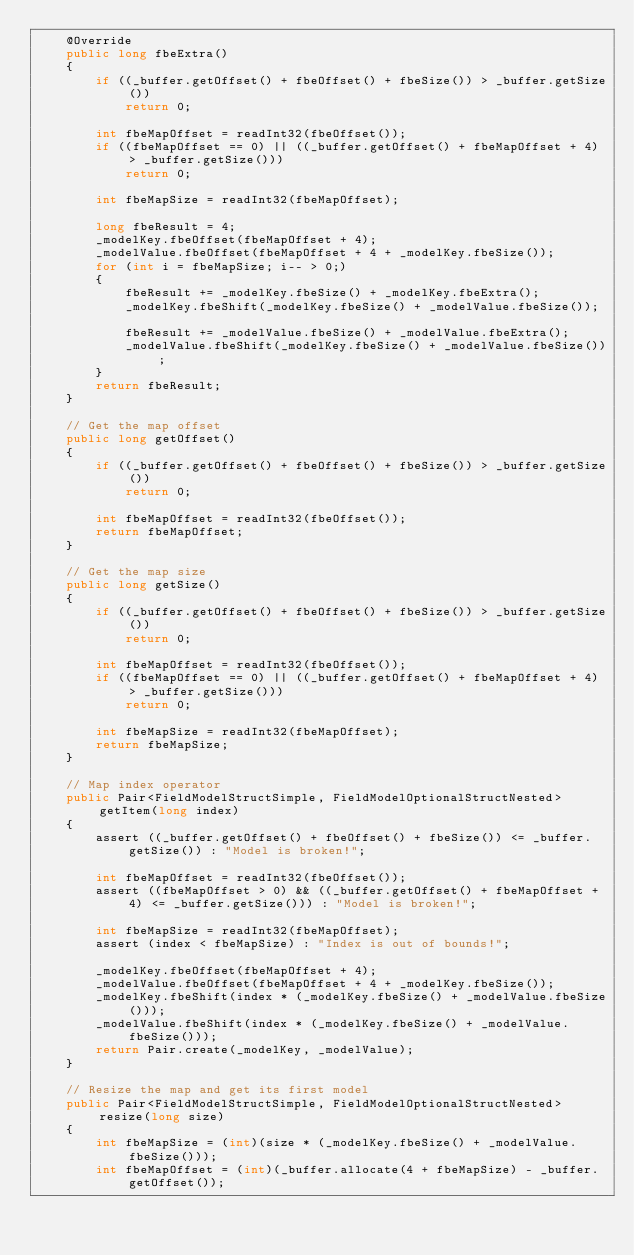Convert code to text. <code><loc_0><loc_0><loc_500><loc_500><_Java_>    @Override
    public long fbeExtra()
    {
        if ((_buffer.getOffset() + fbeOffset() + fbeSize()) > _buffer.getSize())
            return 0;

        int fbeMapOffset = readInt32(fbeOffset());
        if ((fbeMapOffset == 0) || ((_buffer.getOffset() + fbeMapOffset + 4) > _buffer.getSize()))
            return 0;

        int fbeMapSize = readInt32(fbeMapOffset);

        long fbeResult = 4;
        _modelKey.fbeOffset(fbeMapOffset + 4);
        _modelValue.fbeOffset(fbeMapOffset + 4 + _modelKey.fbeSize());
        for (int i = fbeMapSize; i-- > 0;)
        {
            fbeResult += _modelKey.fbeSize() + _modelKey.fbeExtra();
            _modelKey.fbeShift(_modelKey.fbeSize() + _modelValue.fbeSize());

            fbeResult += _modelValue.fbeSize() + _modelValue.fbeExtra();
            _modelValue.fbeShift(_modelKey.fbeSize() + _modelValue.fbeSize());
        }
        return fbeResult;
    }

    // Get the map offset
    public long getOffset()
    {
        if ((_buffer.getOffset() + fbeOffset() + fbeSize()) > _buffer.getSize())
            return 0;

        int fbeMapOffset = readInt32(fbeOffset());
        return fbeMapOffset;
    }

    // Get the map size
    public long getSize()
    {
        if ((_buffer.getOffset() + fbeOffset() + fbeSize()) > _buffer.getSize())
            return 0;

        int fbeMapOffset = readInt32(fbeOffset());
        if ((fbeMapOffset == 0) || ((_buffer.getOffset() + fbeMapOffset + 4) > _buffer.getSize()))
            return 0;

        int fbeMapSize = readInt32(fbeMapOffset);
        return fbeMapSize;
    }

    // Map index operator
    public Pair<FieldModelStructSimple, FieldModelOptionalStructNested> getItem(long index)
    {
        assert ((_buffer.getOffset() + fbeOffset() + fbeSize()) <= _buffer.getSize()) : "Model is broken!";

        int fbeMapOffset = readInt32(fbeOffset());
        assert ((fbeMapOffset > 0) && ((_buffer.getOffset() + fbeMapOffset + 4) <= _buffer.getSize())) : "Model is broken!";

        int fbeMapSize = readInt32(fbeMapOffset);
        assert (index < fbeMapSize) : "Index is out of bounds!";

        _modelKey.fbeOffset(fbeMapOffset + 4);
        _modelValue.fbeOffset(fbeMapOffset + 4 + _modelKey.fbeSize());
        _modelKey.fbeShift(index * (_modelKey.fbeSize() + _modelValue.fbeSize()));
        _modelValue.fbeShift(index * (_modelKey.fbeSize() + _modelValue.fbeSize()));
        return Pair.create(_modelKey, _modelValue);
    }

    // Resize the map and get its first model
    public Pair<FieldModelStructSimple, FieldModelOptionalStructNested> resize(long size)
    {
        int fbeMapSize = (int)(size * (_modelKey.fbeSize() + _modelValue.fbeSize()));
        int fbeMapOffset = (int)(_buffer.allocate(4 + fbeMapSize) - _buffer.getOffset());</code> 